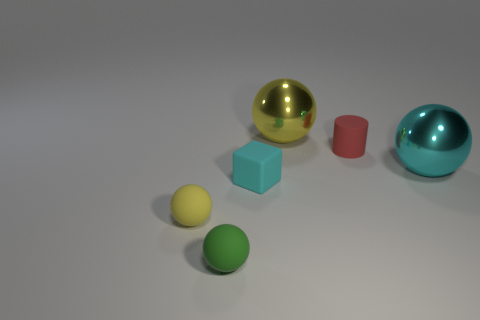Subtract all small yellow balls. How many balls are left? 3 Subtract all cyan spheres. How many spheres are left? 3 Subtract 2 spheres. How many spheres are left? 2 Subtract all brown spheres. Subtract all purple cylinders. How many spheres are left? 4 Add 3 cyan cubes. How many objects exist? 9 Subtract all cylinders. How many objects are left? 5 Subtract 0 red spheres. How many objects are left? 6 Subtract all red matte cylinders. Subtract all yellow metallic spheres. How many objects are left? 4 Add 1 cyan rubber objects. How many cyan rubber objects are left? 2 Add 4 big cyan spheres. How many big cyan spheres exist? 5 